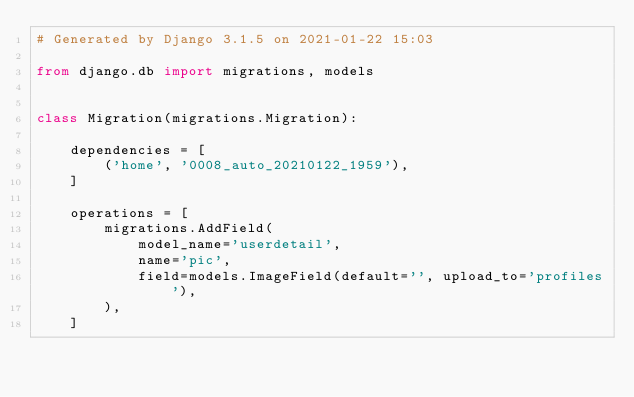<code> <loc_0><loc_0><loc_500><loc_500><_Python_># Generated by Django 3.1.5 on 2021-01-22 15:03

from django.db import migrations, models


class Migration(migrations.Migration):

    dependencies = [
        ('home', '0008_auto_20210122_1959'),
    ]

    operations = [
        migrations.AddField(
            model_name='userdetail',
            name='pic',
            field=models.ImageField(default='', upload_to='profiles'),
        ),
    ]
</code> 